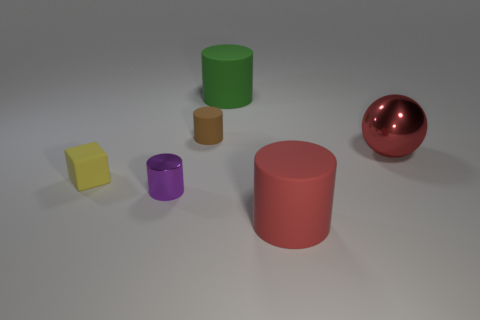Subtract all gray cylinders. Subtract all purple blocks. How many cylinders are left? 4 Add 2 tiny blue shiny balls. How many objects exist? 8 Subtract all cylinders. How many objects are left? 2 Add 5 green matte objects. How many green matte objects exist? 6 Subtract 0 brown cubes. How many objects are left? 6 Subtract all tiny purple matte cylinders. Subtract all small brown rubber cylinders. How many objects are left? 5 Add 6 big metallic things. How many big metallic things are left? 7 